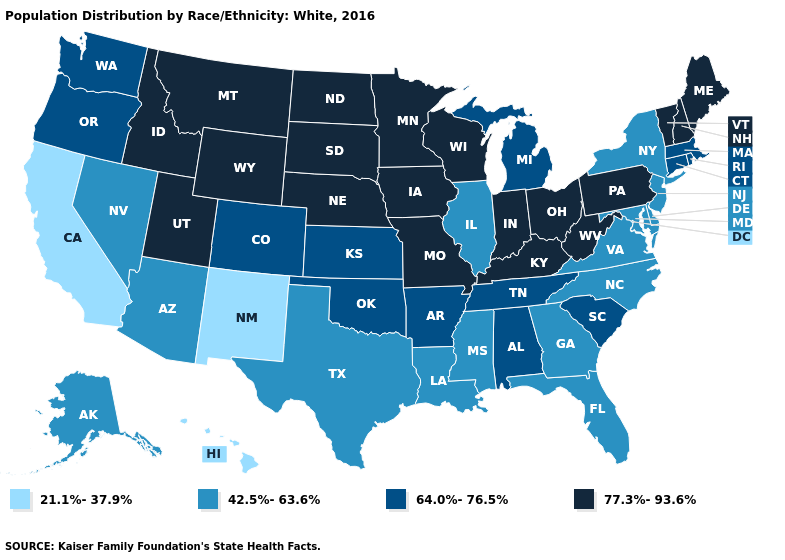Does the first symbol in the legend represent the smallest category?
Quick response, please. Yes. Does Oregon have a higher value than Illinois?
Give a very brief answer. Yes. What is the lowest value in the MidWest?
Quick response, please. 42.5%-63.6%. Name the states that have a value in the range 64.0%-76.5%?
Short answer required. Alabama, Arkansas, Colorado, Connecticut, Kansas, Massachusetts, Michigan, Oklahoma, Oregon, Rhode Island, South Carolina, Tennessee, Washington. Name the states that have a value in the range 42.5%-63.6%?
Concise answer only. Alaska, Arizona, Delaware, Florida, Georgia, Illinois, Louisiana, Maryland, Mississippi, Nevada, New Jersey, New York, North Carolina, Texas, Virginia. What is the value of Tennessee?
Be succinct. 64.0%-76.5%. Which states have the lowest value in the MidWest?
Concise answer only. Illinois. What is the value of Arkansas?
Be succinct. 64.0%-76.5%. What is the value of North Carolina?
Be succinct. 42.5%-63.6%. Does Colorado have the highest value in the West?
Concise answer only. No. Does Virginia have a higher value than Kentucky?
Give a very brief answer. No. What is the value of Iowa?
Keep it brief. 77.3%-93.6%. Does Idaho have the highest value in the USA?
Be succinct. Yes. What is the value of Delaware?
Keep it brief. 42.5%-63.6%. 